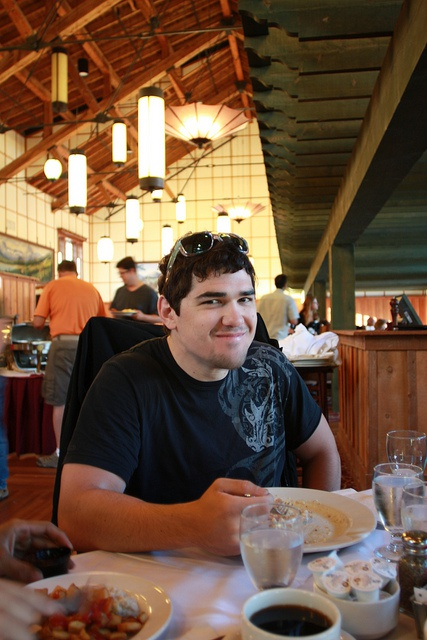Describe the objects in this image and their specific colors. I can see people in maroon, black, and brown tones, dining table in maroon, darkgray, gray, and tan tones, people in maroon, red, black, and brown tones, people in maroon, gray, and black tones, and cup in maroon and gray tones in this image. 